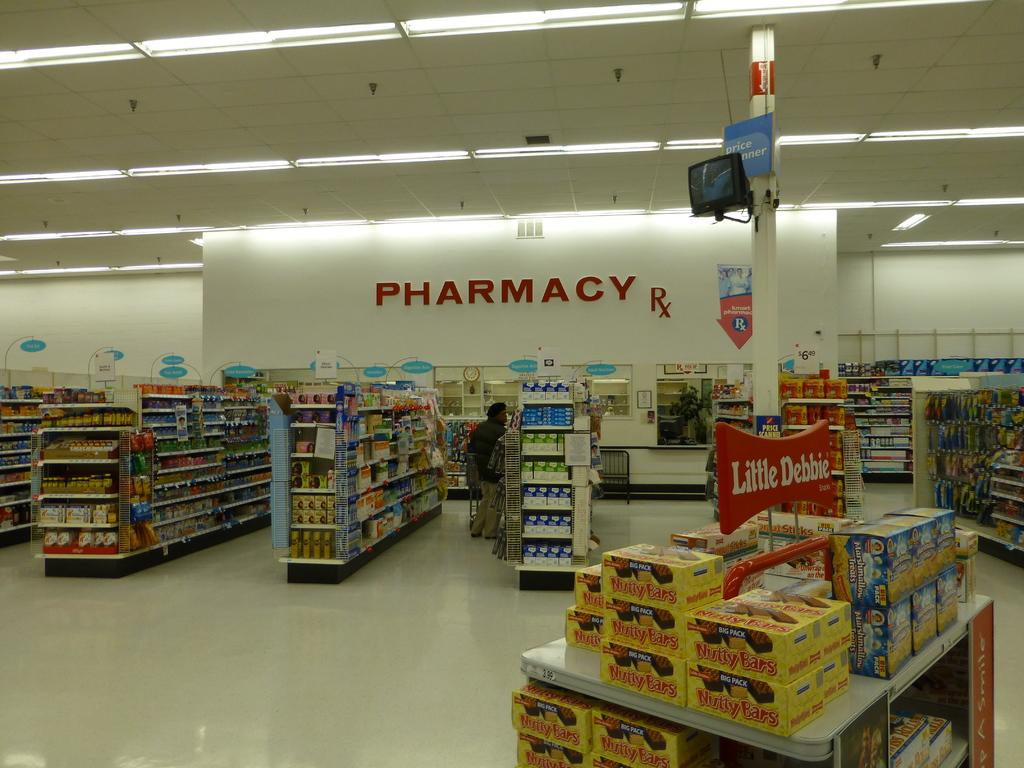<image>
Create a compact narrative representing the image presented. A store with the Pharmacy in red in the back. 